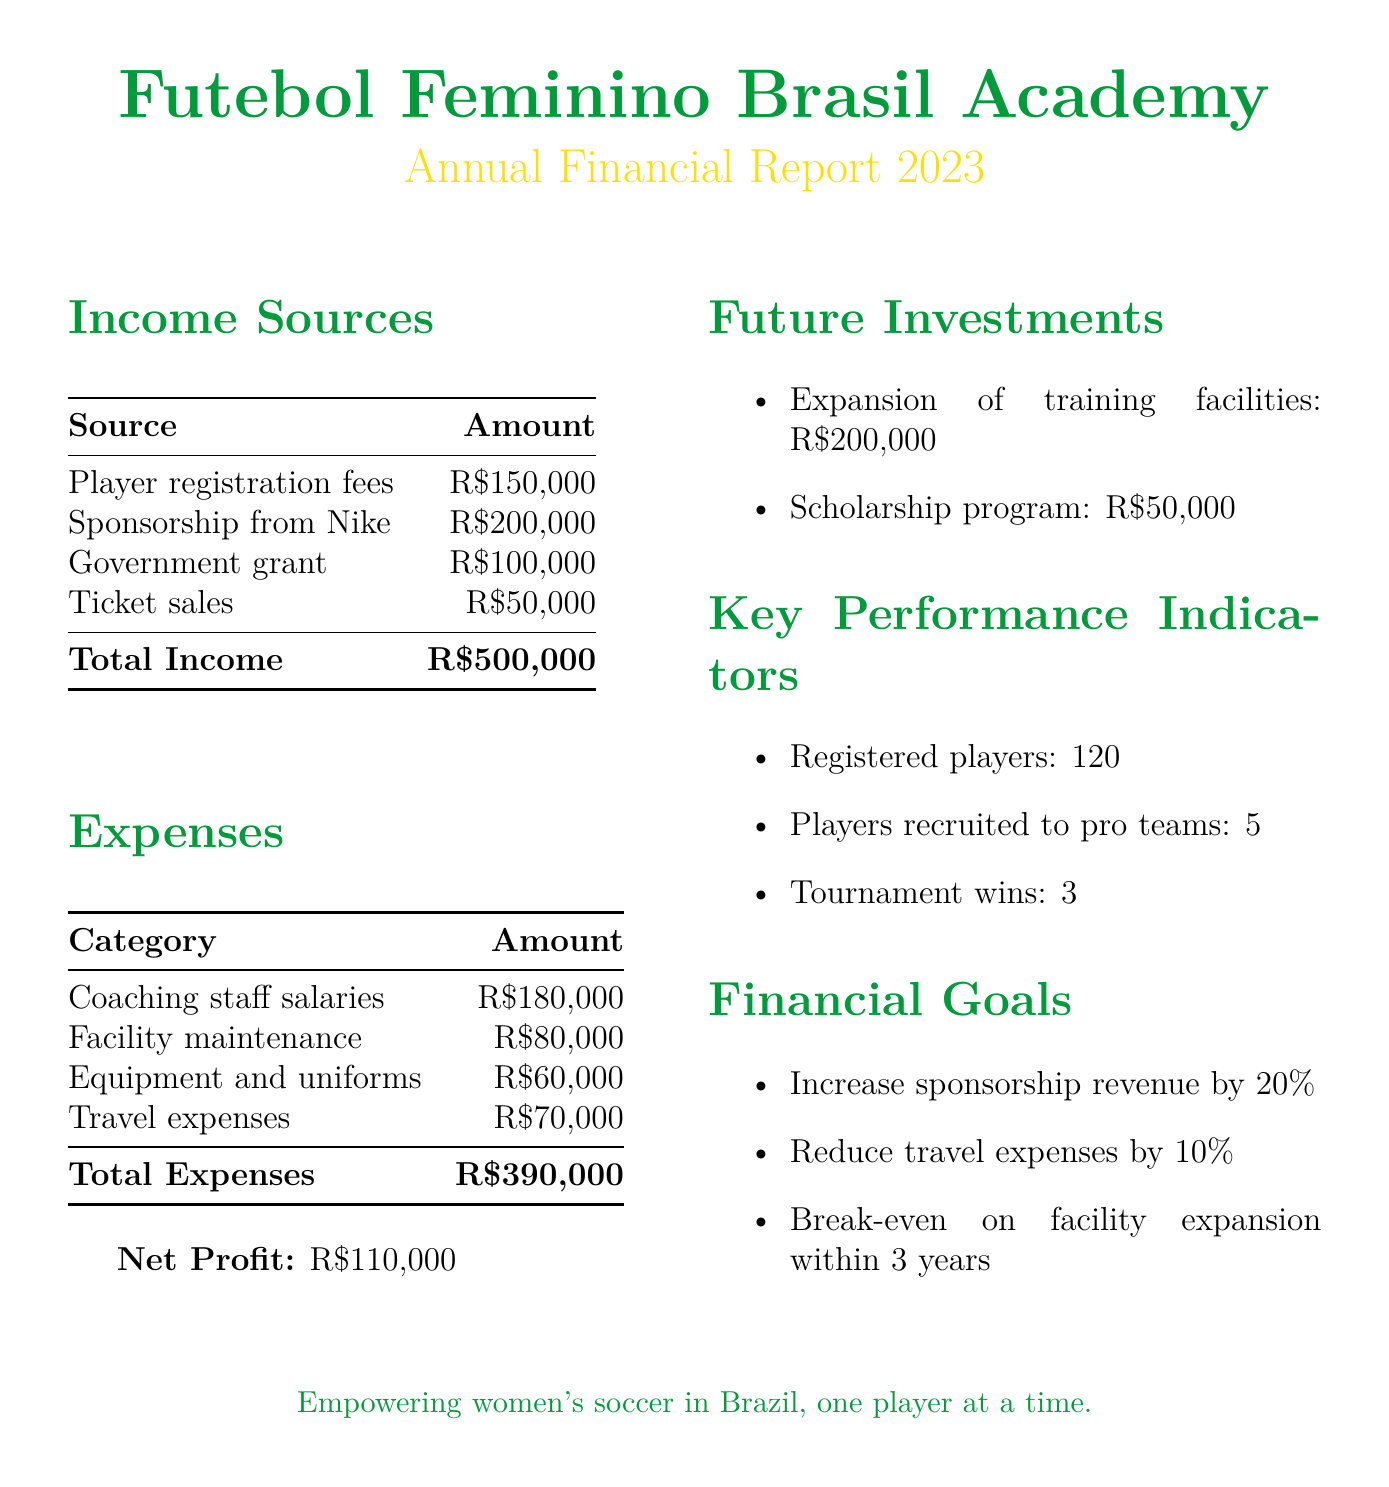What is the total income? The total income is the sum of all income sources listed in the document, which is R$150,000 + R$200,000 + R$100,000 + R$50,000 = R$500,000.
Answer: R$500,000 What is the net profit for the financial year? The net profit is calculated by subtracting total expenses from total income, which is R$500,000 - R$390,000 = R$110,000.
Answer: R$110,000 How much is allocated for the scholarship program? The document specifies the estimated cost for the scholarship program as R$50,000.
Answer: R$50,000 What percentage increase in sponsorship revenue is targeted for next year? The document states that the goal is to increase sponsorship revenue by 20%.
Answer: 20% How many registered players are there? The document lists the number of registered players as 120.
Answer: 120 What is the total expense for coaching staff salaries? The document states the expense for coaching staff salaries as R$180,000.
Answer: R$180,000 What is one goal related to travel expenses? The document mentions a goal to reduce travel expenses by 10% through optimized scheduling.
Answer: Reduce travel expenses by 10% How many tournament wins were recorded? The document reports that there were 3 tournament wins.
Answer: 3 What is the estimated cost for expanding training facilities? The document indicates that the estimated cost for the expansion of training facilities is R$200,000.
Answer: R$200,000 